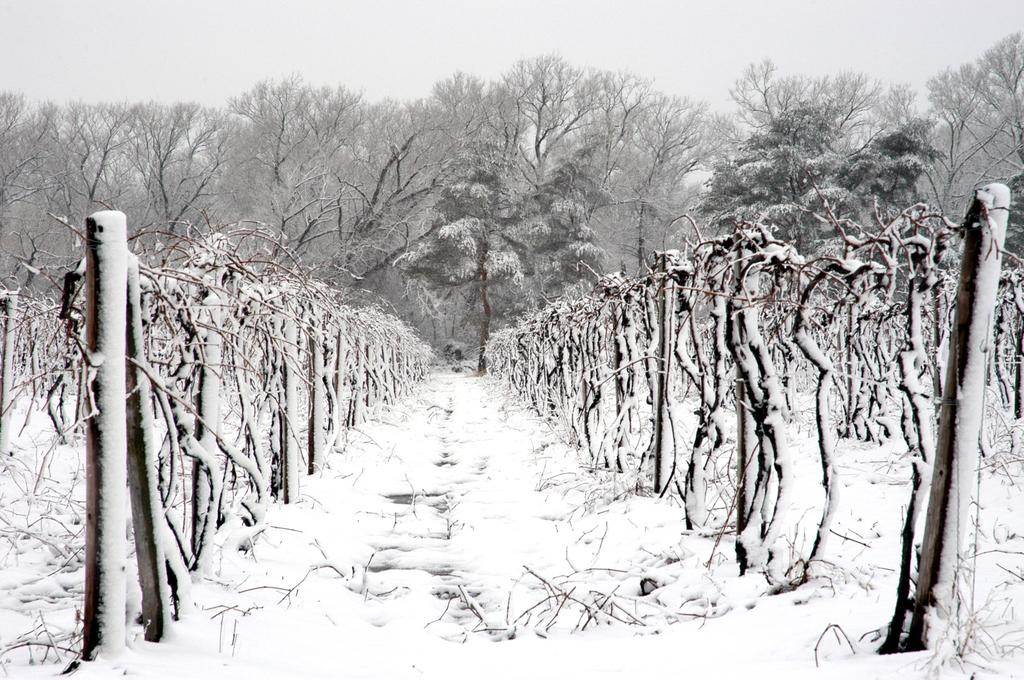What type of vegetation can be seen in the image? There are trees in the image. Can you describe the trees in the image? The provided facts do not give specific details about the trees, so we cannot describe them further. What type of button can be seen on the vase in the image? There is no vase or button present in the image; it only features trees. 